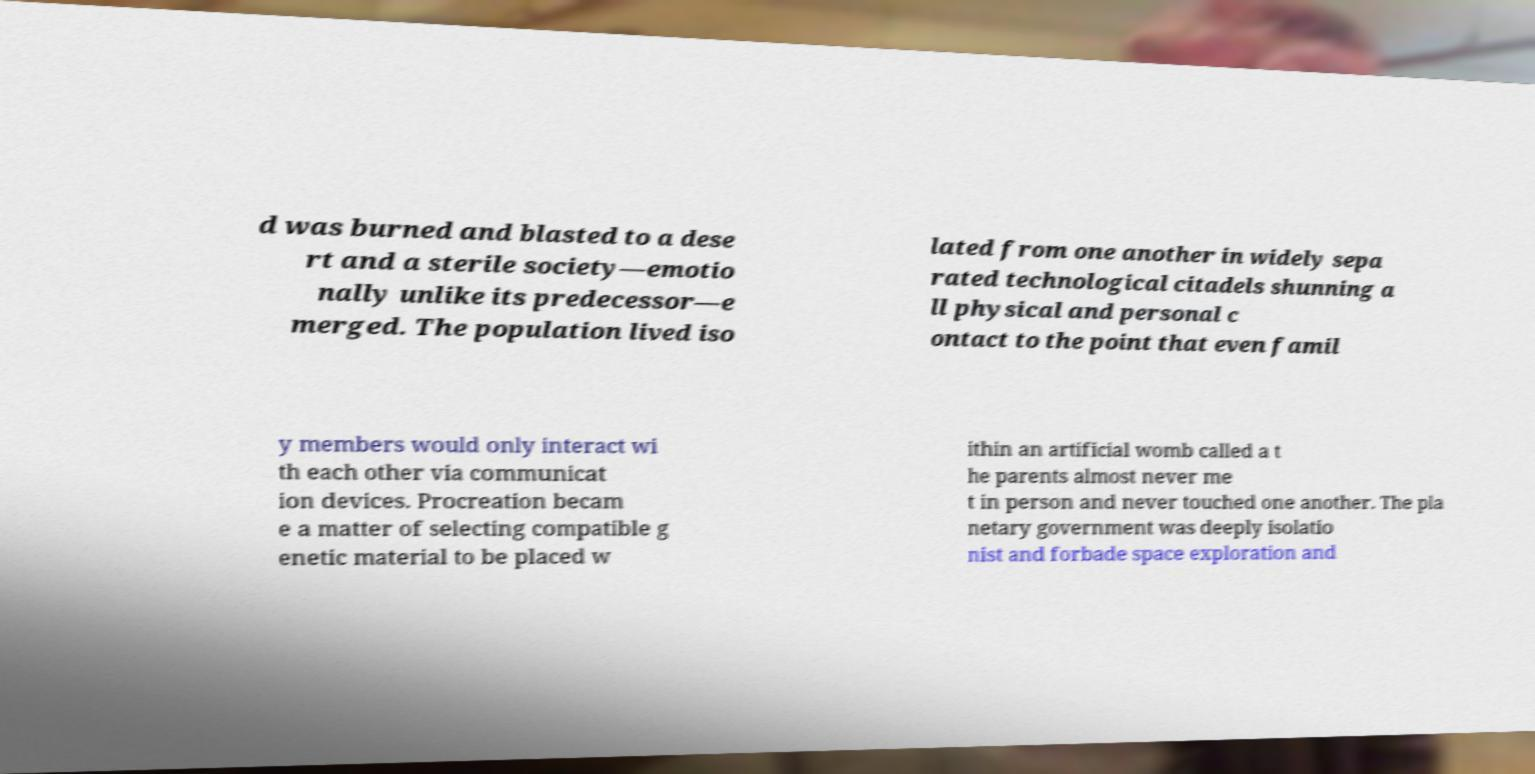What messages or text are displayed in this image? I need them in a readable, typed format. d was burned and blasted to a dese rt and a sterile society—emotio nally unlike its predecessor—e merged. The population lived iso lated from one another in widely sepa rated technological citadels shunning a ll physical and personal c ontact to the point that even famil y members would only interact wi th each other via communicat ion devices. Procreation becam e a matter of selecting compatible g enetic material to be placed w ithin an artificial womb called a t he parents almost never me t in person and never touched one another. The pla netary government was deeply isolatio nist and forbade space exploration and 